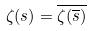<formula> <loc_0><loc_0><loc_500><loc_500>\zeta ( s ) = \overline { \zeta ( \overline { s } ) }</formula> 